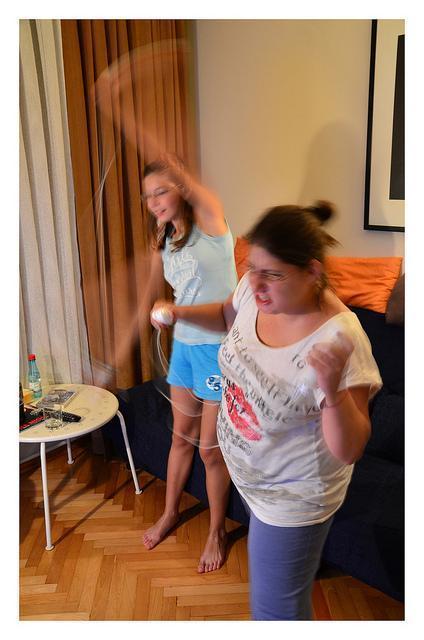How many people are there?
Give a very brief answer. 2. How many people can be seen?
Give a very brief answer. 2. How many giraffes are there?
Give a very brief answer. 0. 